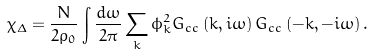Convert formula to latex. <formula><loc_0><loc_0><loc_500><loc_500>\chi _ { \Delta } = \frac { N } { 2 \rho _ { 0 } } \int \frac { d \omega } { 2 \pi } \sum _ { k } \phi _ { k } ^ { 2 } G _ { c c } \left ( k , i \omega \right ) G _ { c c } \left ( - k , - i \omega \right ) .</formula> 